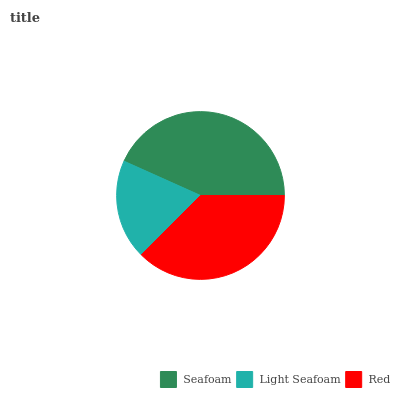Is Light Seafoam the minimum?
Answer yes or no. Yes. Is Seafoam the maximum?
Answer yes or no. Yes. Is Red the minimum?
Answer yes or no. No. Is Red the maximum?
Answer yes or no. No. Is Red greater than Light Seafoam?
Answer yes or no. Yes. Is Light Seafoam less than Red?
Answer yes or no. Yes. Is Light Seafoam greater than Red?
Answer yes or no. No. Is Red less than Light Seafoam?
Answer yes or no. No. Is Red the high median?
Answer yes or no. Yes. Is Red the low median?
Answer yes or no. Yes. Is Seafoam the high median?
Answer yes or no. No. Is Light Seafoam the low median?
Answer yes or no. No. 